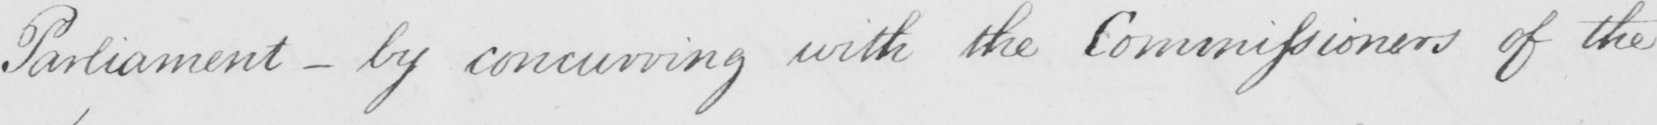Please transcribe the handwritten text in this image. Parliament  _  by concurring with the Commissioners of the 